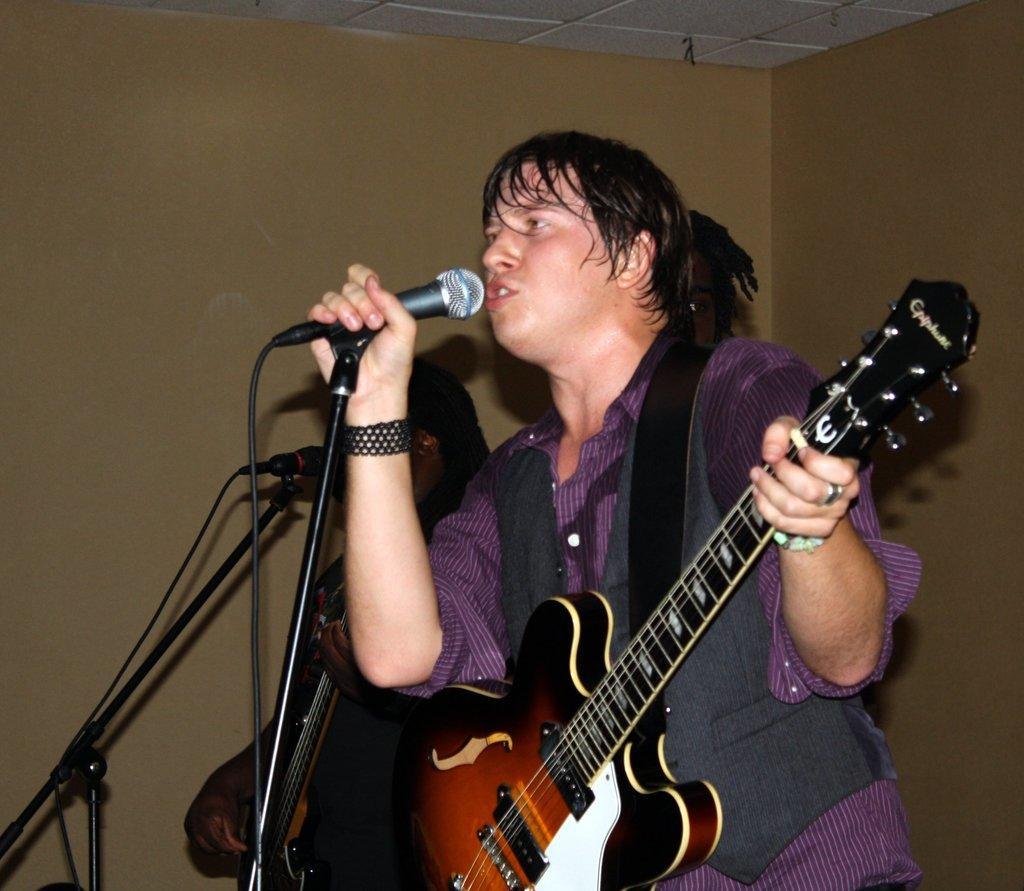Could you give a brief overview of what you see in this image? A person is standing,holding a guitar behind this person there is a wall. 